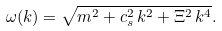Convert formula to latex. <formula><loc_0><loc_0><loc_500><loc_500>\omega ( k ) = \sqrt { m ^ { 2 } + c _ { s } ^ { 2 } \, k ^ { 2 } + \Xi ^ { 2 } \, k ^ { 4 } } .</formula> 